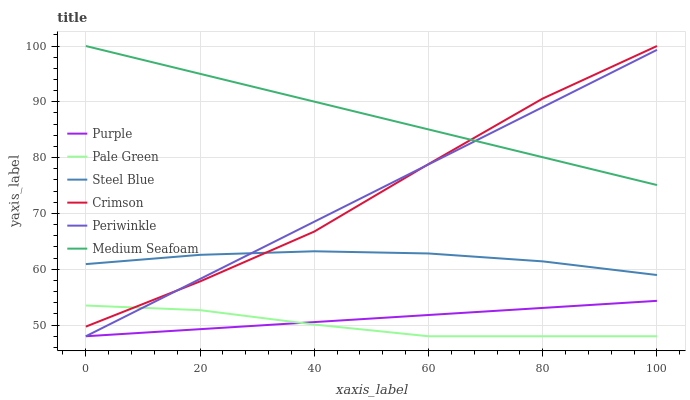Does Pale Green have the minimum area under the curve?
Answer yes or no. Yes. Does Steel Blue have the minimum area under the curve?
Answer yes or no. No. Does Steel Blue have the maximum area under the curve?
Answer yes or no. No. Is Steel Blue the smoothest?
Answer yes or no. No. Is Steel Blue the roughest?
Answer yes or no. No. Does Steel Blue have the lowest value?
Answer yes or no. No. Does Steel Blue have the highest value?
Answer yes or no. No. Is Purple less than Steel Blue?
Answer yes or no. Yes. Is Medium Seafoam greater than Pale Green?
Answer yes or no. Yes. Does Purple intersect Steel Blue?
Answer yes or no. No. 